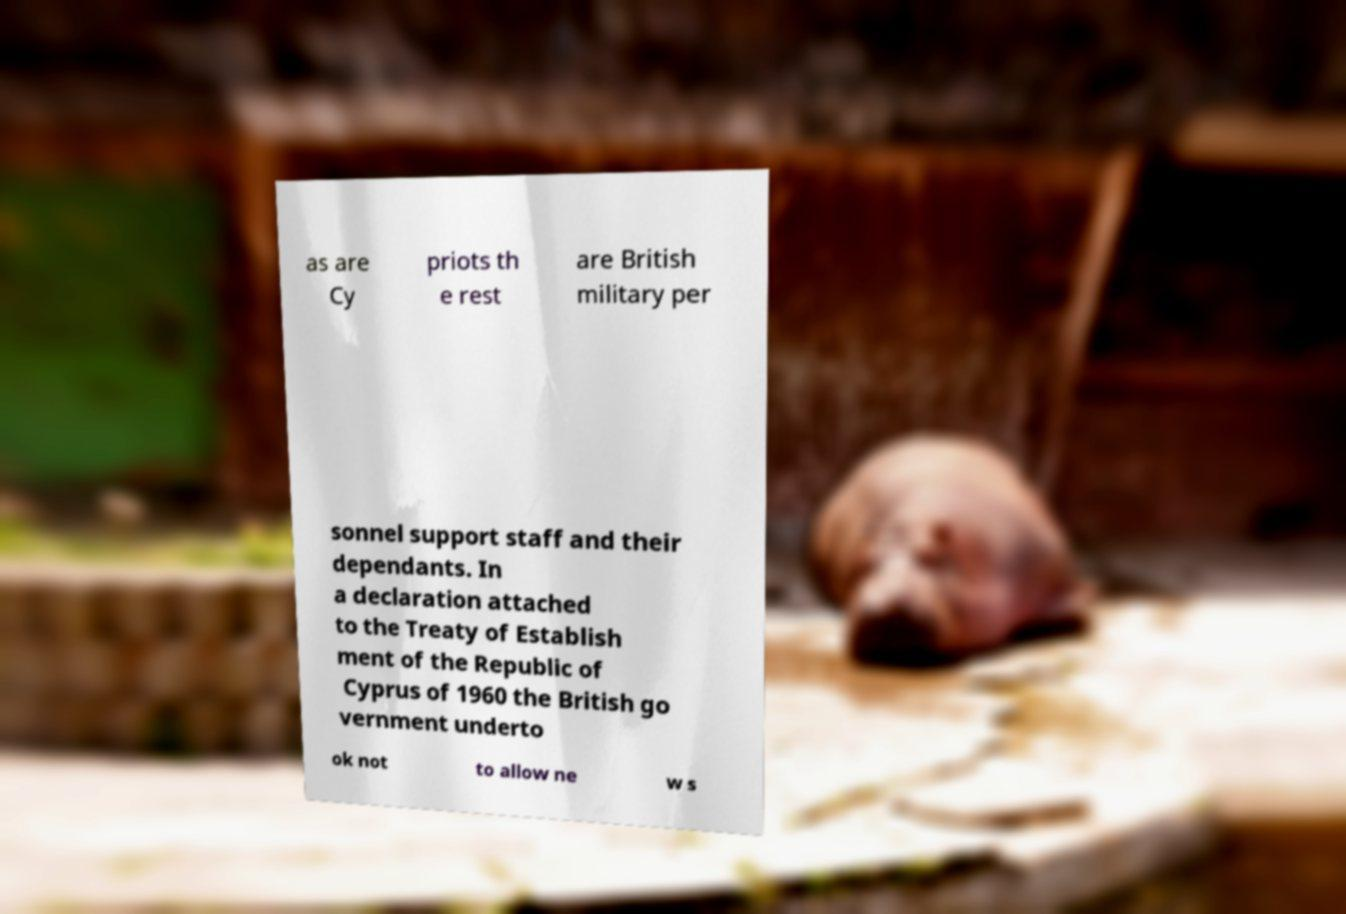There's text embedded in this image that I need extracted. Can you transcribe it verbatim? as are Cy priots th e rest are British military per sonnel support staff and their dependants. In a declaration attached to the Treaty of Establish ment of the Republic of Cyprus of 1960 the British go vernment underto ok not to allow ne w s 